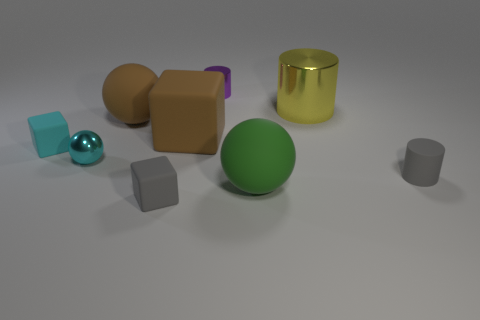There is a object that is the same color as the metal ball; what shape is it?
Ensure brevity in your answer.  Cube. Are there fewer metal spheres that are in front of the small rubber cylinder than small purple metal cylinders?
Your response must be concise. Yes. Is the tiny purple metallic thing the same shape as the big yellow thing?
Provide a succinct answer. Yes. What size is the cyan block that is the same material as the large brown block?
Your answer should be very brief. Small. Are there fewer small gray metal balls than small rubber cubes?
Make the answer very short. Yes. How many large things are either brown cubes or cyan metallic balls?
Ensure brevity in your answer.  1. How many big spheres are both behind the tiny sphere and right of the big brown ball?
Offer a terse response. 0. Are there more tiny matte cylinders than brown cylinders?
Ensure brevity in your answer.  Yes. How many other objects are there of the same shape as the yellow object?
Provide a short and direct response. 2. Is the big metallic object the same color as the matte cylinder?
Offer a terse response. No. 